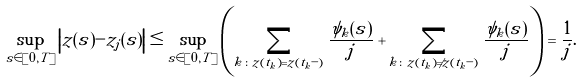Convert formula to latex. <formula><loc_0><loc_0><loc_500><loc_500>\sup _ { s \in [ 0 , T ] } \left | z ( s ) - z _ { j } ( s ) \right | \leq \sup _ { s \in [ 0 , T ] } \left ( \sum _ { k \colon z ( t _ { k } ) = z ( t _ { k } - ) } \frac { \psi _ { k } ( s ) } { j } + \sum _ { k \colon z ( t _ { k } ) \neq z ( t _ { k } - ) } \frac { \psi _ { k } ( s ) } { j } \right ) = \frac { 1 } { j } .</formula> 